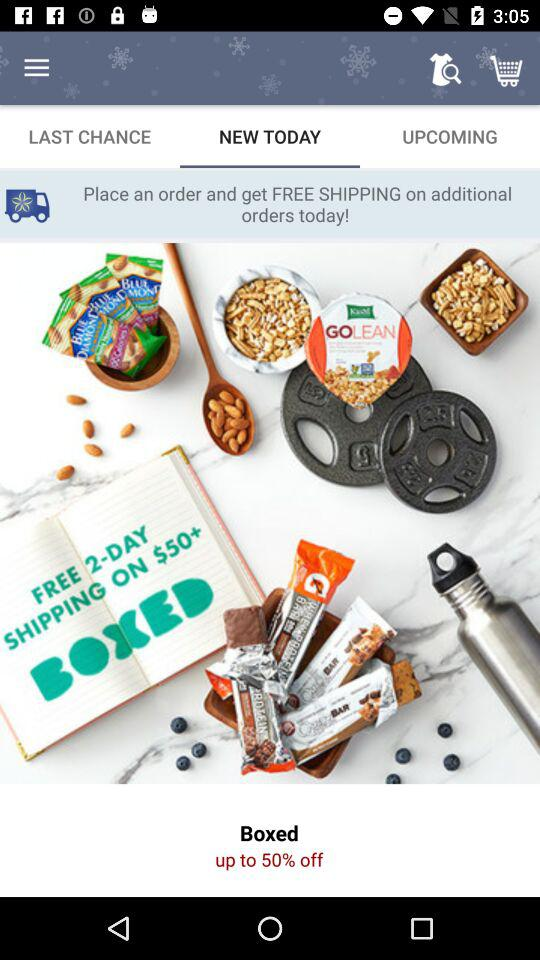What is the percentage of the discount on the product?
Answer the question using a single word or phrase. 50% 